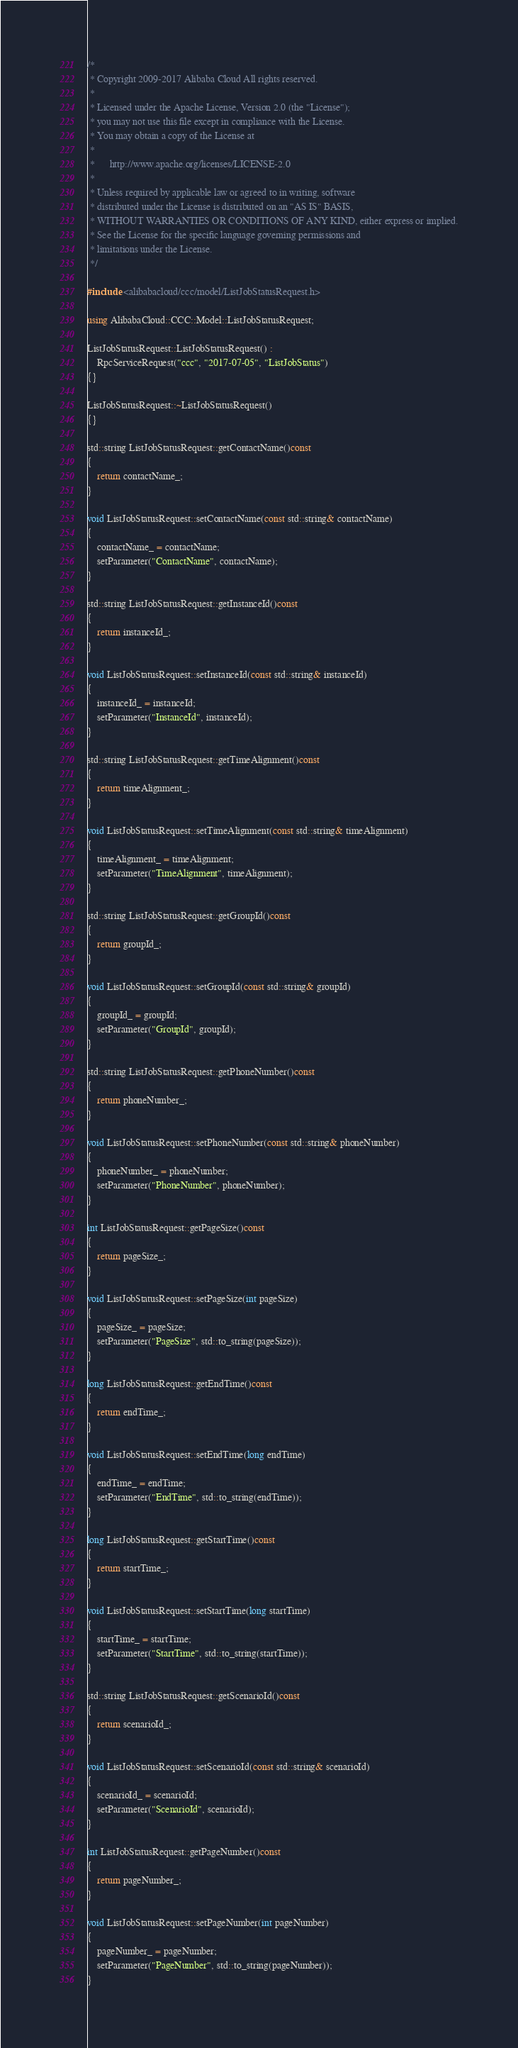Convert code to text. <code><loc_0><loc_0><loc_500><loc_500><_C++_>/*
 * Copyright 2009-2017 Alibaba Cloud All rights reserved.
 * 
 * Licensed under the Apache License, Version 2.0 (the "License");
 * you may not use this file except in compliance with the License.
 * You may obtain a copy of the License at
 * 
 *      http://www.apache.org/licenses/LICENSE-2.0
 * 
 * Unless required by applicable law or agreed to in writing, software
 * distributed under the License is distributed on an "AS IS" BASIS,
 * WITHOUT WARRANTIES OR CONDITIONS OF ANY KIND, either express or implied.
 * See the License for the specific language governing permissions and
 * limitations under the License.
 */

#include <alibabacloud/ccc/model/ListJobStatusRequest.h>

using AlibabaCloud::CCC::Model::ListJobStatusRequest;

ListJobStatusRequest::ListJobStatusRequest() :
	RpcServiceRequest("ccc", "2017-07-05", "ListJobStatus")
{}

ListJobStatusRequest::~ListJobStatusRequest()
{}

std::string ListJobStatusRequest::getContactName()const
{
	return contactName_;
}

void ListJobStatusRequest::setContactName(const std::string& contactName)
{
	contactName_ = contactName;
	setParameter("ContactName", contactName);
}

std::string ListJobStatusRequest::getInstanceId()const
{
	return instanceId_;
}

void ListJobStatusRequest::setInstanceId(const std::string& instanceId)
{
	instanceId_ = instanceId;
	setParameter("InstanceId", instanceId);
}

std::string ListJobStatusRequest::getTimeAlignment()const
{
	return timeAlignment_;
}

void ListJobStatusRequest::setTimeAlignment(const std::string& timeAlignment)
{
	timeAlignment_ = timeAlignment;
	setParameter("TimeAlignment", timeAlignment);
}

std::string ListJobStatusRequest::getGroupId()const
{
	return groupId_;
}

void ListJobStatusRequest::setGroupId(const std::string& groupId)
{
	groupId_ = groupId;
	setParameter("GroupId", groupId);
}

std::string ListJobStatusRequest::getPhoneNumber()const
{
	return phoneNumber_;
}

void ListJobStatusRequest::setPhoneNumber(const std::string& phoneNumber)
{
	phoneNumber_ = phoneNumber;
	setParameter("PhoneNumber", phoneNumber);
}

int ListJobStatusRequest::getPageSize()const
{
	return pageSize_;
}

void ListJobStatusRequest::setPageSize(int pageSize)
{
	pageSize_ = pageSize;
	setParameter("PageSize", std::to_string(pageSize));
}

long ListJobStatusRequest::getEndTime()const
{
	return endTime_;
}

void ListJobStatusRequest::setEndTime(long endTime)
{
	endTime_ = endTime;
	setParameter("EndTime", std::to_string(endTime));
}

long ListJobStatusRequest::getStartTime()const
{
	return startTime_;
}

void ListJobStatusRequest::setStartTime(long startTime)
{
	startTime_ = startTime;
	setParameter("StartTime", std::to_string(startTime));
}

std::string ListJobStatusRequest::getScenarioId()const
{
	return scenarioId_;
}

void ListJobStatusRequest::setScenarioId(const std::string& scenarioId)
{
	scenarioId_ = scenarioId;
	setParameter("ScenarioId", scenarioId);
}

int ListJobStatusRequest::getPageNumber()const
{
	return pageNumber_;
}

void ListJobStatusRequest::setPageNumber(int pageNumber)
{
	pageNumber_ = pageNumber;
	setParameter("PageNumber", std::to_string(pageNumber));
}

</code> 